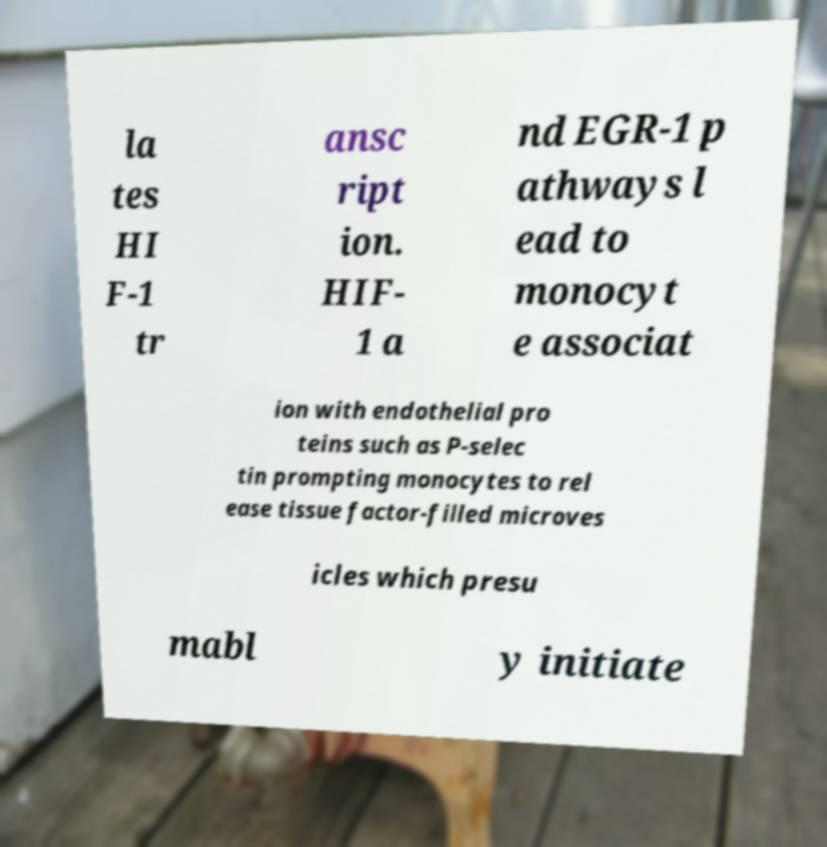Could you extract and type out the text from this image? la tes HI F-1 tr ansc ript ion. HIF- 1 a nd EGR-1 p athways l ead to monocyt e associat ion with endothelial pro teins such as P-selec tin prompting monocytes to rel ease tissue factor-filled microves icles which presu mabl y initiate 